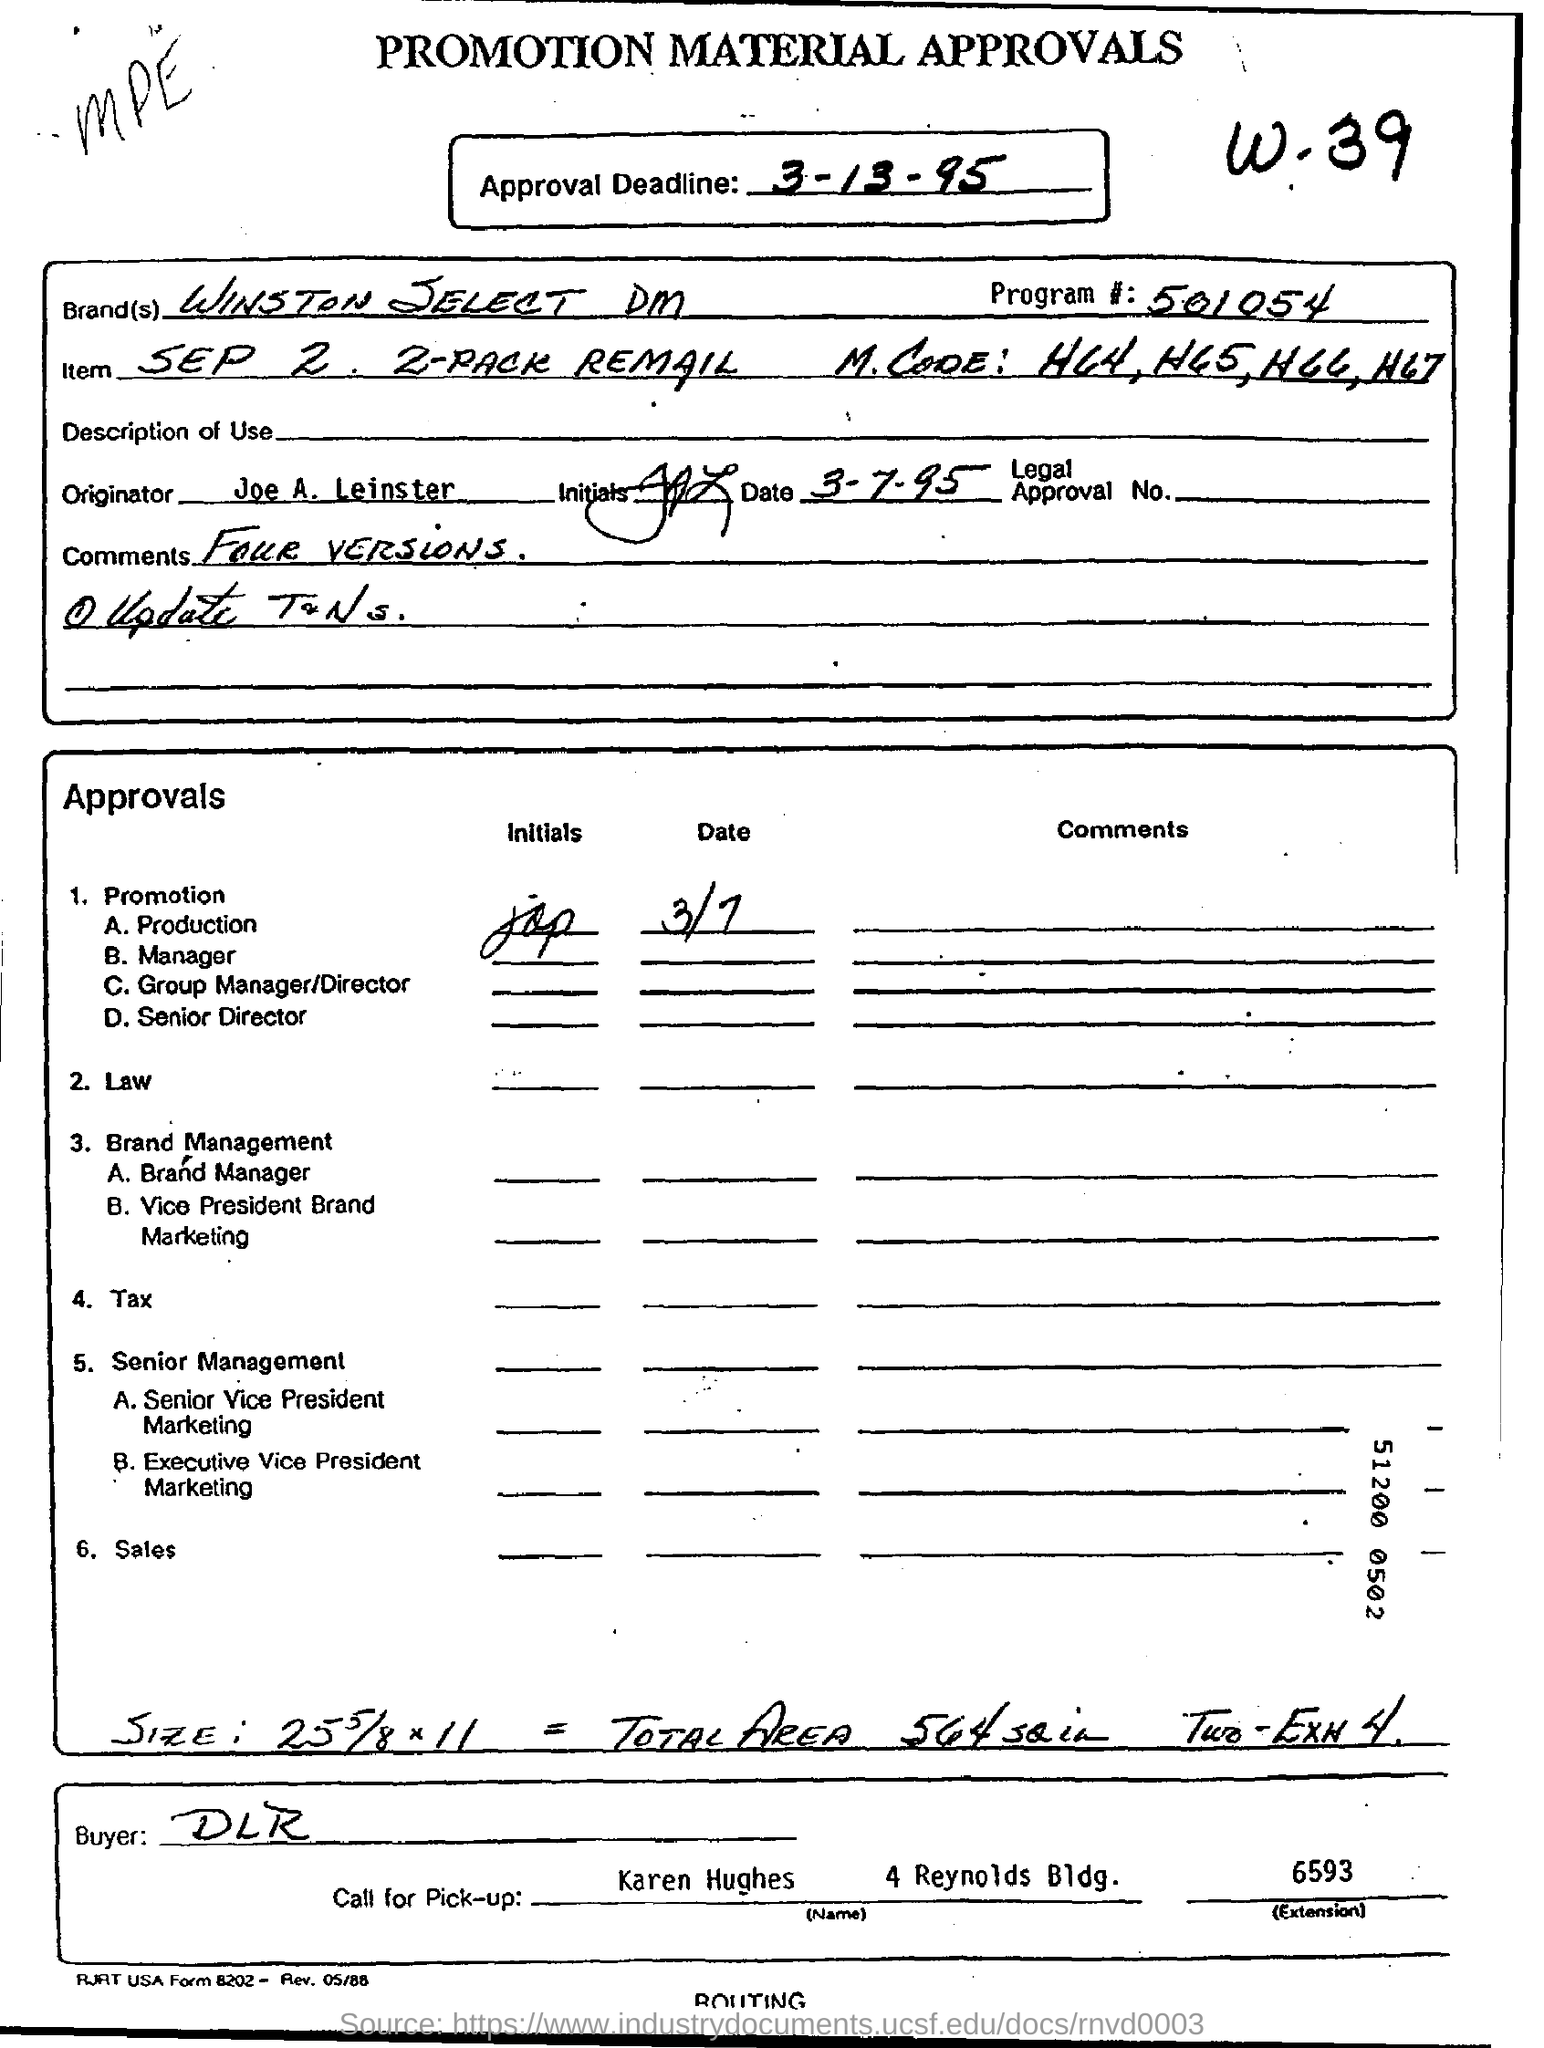What was the approval deadline?
Provide a short and direct response. 3-13-95. What is the brand name?
Keep it short and to the point. Winston select dm. What is the main title of paper?
Ensure brevity in your answer.  PROMOTION MATERIAL APPROVALS. What is the last approval in the given list
Ensure brevity in your answer.  Sales. 